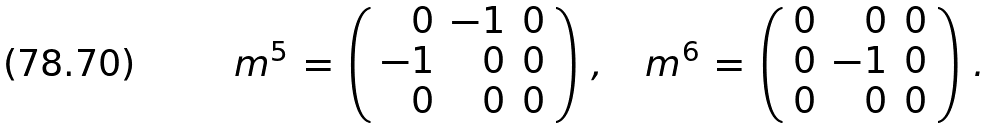<formula> <loc_0><loc_0><loc_500><loc_500>m ^ { 5 } \, = \, \left ( \begin{array} { r r r } 0 & - 1 & 0 \\ - 1 & 0 & 0 \\ 0 & 0 & 0 \end{array} \right ) \, , \quad m ^ { 6 } \, = \, \left ( \begin{array} { r r r } 0 & 0 & 0 \\ 0 & - 1 & 0 \\ 0 & 0 & 0 \end{array} \right ) \, .</formula> 